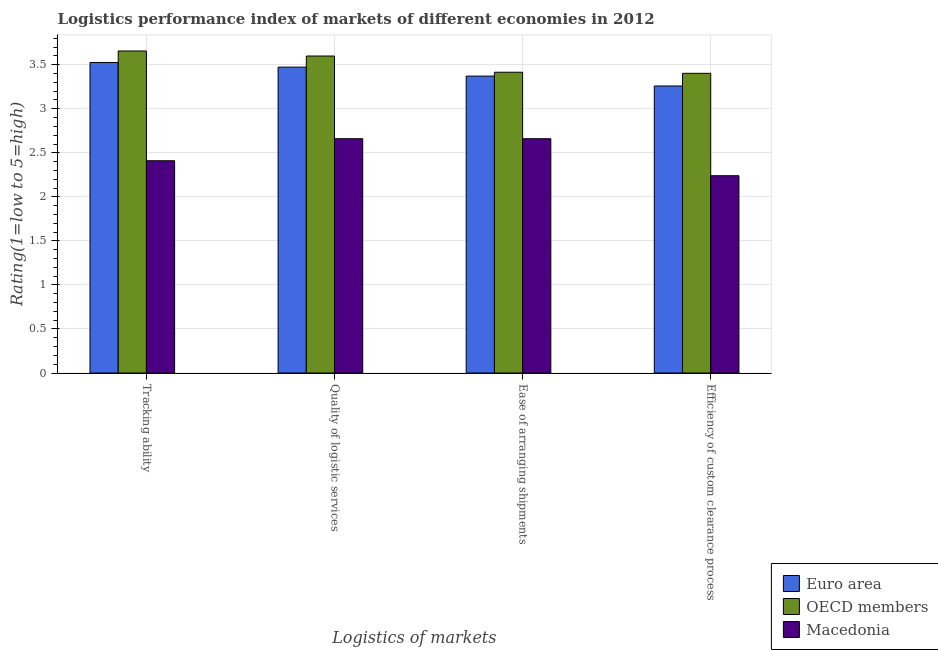How many groups of bars are there?
Your answer should be compact. 4. Are the number of bars per tick equal to the number of legend labels?
Provide a short and direct response. Yes. How many bars are there on the 4th tick from the right?
Give a very brief answer. 3. What is the label of the 3rd group of bars from the left?
Offer a terse response. Ease of arranging shipments. What is the lpi rating of tracking ability in Macedonia?
Your answer should be compact. 2.41. Across all countries, what is the maximum lpi rating of ease of arranging shipments?
Ensure brevity in your answer.  3.42. Across all countries, what is the minimum lpi rating of efficiency of custom clearance process?
Ensure brevity in your answer.  2.24. In which country was the lpi rating of quality of logistic services minimum?
Your answer should be compact. Macedonia. What is the total lpi rating of ease of arranging shipments in the graph?
Offer a terse response. 9.45. What is the difference between the lpi rating of ease of arranging shipments in Macedonia and that in Euro area?
Give a very brief answer. -0.71. What is the difference between the lpi rating of ease of arranging shipments in Macedonia and the lpi rating of tracking ability in OECD members?
Give a very brief answer. -1. What is the average lpi rating of quality of logistic services per country?
Ensure brevity in your answer.  3.24. What is the difference between the lpi rating of tracking ability and lpi rating of ease of arranging shipments in Euro area?
Offer a terse response. 0.15. In how many countries, is the lpi rating of quality of logistic services greater than 2 ?
Provide a succinct answer. 3. What is the ratio of the lpi rating of ease of arranging shipments in OECD members to that in Euro area?
Give a very brief answer. 1.01. Is the difference between the lpi rating of ease of arranging shipments in OECD members and Euro area greater than the difference between the lpi rating of tracking ability in OECD members and Euro area?
Make the answer very short. No. What is the difference between the highest and the second highest lpi rating of ease of arranging shipments?
Your answer should be compact. 0.04. What is the difference between the highest and the lowest lpi rating of tracking ability?
Your response must be concise. 1.25. Is the sum of the lpi rating of efficiency of custom clearance process in Macedonia and Euro area greater than the maximum lpi rating of tracking ability across all countries?
Provide a short and direct response. Yes. What does the 2nd bar from the left in Tracking ability represents?
Your answer should be compact. OECD members. What does the 1st bar from the right in Tracking ability represents?
Your answer should be compact. Macedonia. Is it the case that in every country, the sum of the lpi rating of tracking ability and lpi rating of quality of logistic services is greater than the lpi rating of ease of arranging shipments?
Make the answer very short. Yes. How many bars are there?
Provide a succinct answer. 12. How many countries are there in the graph?
Provide a succinct answer. 3. What is the difference between two consecutive major ticks on the Y-axis?
Keep it short and to the point. 0.5. Are the values on the major ticks of Y-axis written in scientific E-notation?
Your answer should be very brief. No. Does the graph contain grids?
Ensure brevity in your answer.  Yes. Where does the legend appear in the graph?
Keep it short and to the point. Bottom right. How many legend labels are there?
Ensure brevity in your answer.  3. How are the legend labels stacked?
Your response must be concise. Vertical. What is the title of the graph?
Provide a succinct answer. Logistics performance index of markets of different economies in 2012. What is the label or title of the X-axis?
Your answer should be compact. Logistics of markets. What is the label or title of the Y-axis?
Offer a very short reply. Rating(1=low to 5=high). What is the Rating(1=low to 5=high) in Euro area in Tracking ability?
Keep it short and to the point. 3.53. What is the Rating(1=low to 5=high) in OECD members in Tracking ability?
Offer a terse response. 3.66. What is the Rating(1=low to 5=high) of Macedonia in Tracking ability?
Provide a short and direct response. 2.41. What is the Rating(1=low to 5=high) of Euro area in Quality of logistic services?
Your response must be concise. 3.47. What is the Rating(1=low to 5=high) in OECD members in Quality of logistic services?
Give a very brief answer. 3.6. What is the Rating(1=low to 5=high) of Macedonia in Quality of logistic services?
Give a very brief answer. 2.66. What is the Rating(1=low to 5=high) in Euro area in Ease of arranging shipments?
Keep it short and to the point. 3.37. What is the Rating(1=low to 5=high) in OECD members in Ease of arranging shipments?
Provide a short and direct response. 3.42. What is the Rating(1=low to 5=high) in Macedonia in Ease of arranging shipments?
Provide a succinct answer. 2.66. What is the Rating(1=low to 5=high) in Euro area in Efficiency of custom clearance process?
Ensure brevity in your answer.  3.26. What is the Rating(1=low to 5=high) in OECD members in Efficiency of custom clearance process?
Provide a succinct answer. 3.4. What is the Rating(1=low to 5=high) in Macedonia in Efficiency of custom clearance process?
Provide a short and direct response. 2.24. Across all Logistics of markets, what is the maximum Rating(1=low to 5=high) of Euro area?
Ensure brevity in your answer.  3.53. Across all Logistics of markets, what is the maximum Rating(1=low to 5=high) of OECD members?
Offer a terse response. 3.66. Across all Logistics of markets, what is the maximum Rating(1=low to 5=high) of Macedonia?
Your response must be concise. 2.66. Across all Logistics of markets, what is the minimum Rating(1=low to 5=high) in Euro area?
Your answer should be compact. 3.26. Across all Logistics of markets, what is the minimum Rating(1=low to 5=high) of OECD members?
Give a very brief answer. 3.4. Across all Logistics of markets, what is the minimum Rating(1=low to 5=high) in Macedonia?
Keep it short and to the point. 2.24. What is the total Rating(1=low to 5=high) in Euro area in the graph?
Ensure brevity in your answer.  13.63. What is the total Rating(1=low to 5=high) of OECD members in the graph?
Give a very brief answer. 14.07. What is the total Rating(1=low to 5=high) of Macedonia in the graph?
Make the answer very short. 9.97. What is the difference between the Rating(1=low to 5=high) of Euro area in Tracking ability and that in Quality of logistic services?
Your response must be concise. 0.05. What is the difference between the Rating(1=low to 5=high) in OECD members in Tracking ability and that in Quality of logistic services?
Give a very brief answer. 0.06. What is the difference between the Rating(1=low to 5=high) of Macedonia in Tracking ability and that in Quality of logistic services?
Ensure brevity in your answer.  -0.25. What is the difference between the Rating(1=low to 5=high) in Euro area in Tracking ability and that in Ease of arranging shipments?
Give a very brief answer. 0.15. What is the difference between the Rating(1=low to 5=high) in OECD members in Tracking ability and that in Ease of arranging shipments?
Your response must be concise. 0.24. What is the difference between the Rating(1=low to 5=high) in Macedonia in Tracking ability and that in Ease of arranging shipments?
Make the answer very short. -0.25. What is the difference between the Rating(1=low to 5=high) in Euro area in Tracking ability and that in Efficiency of custom clearance process?
Provide a short and direct response. 0.27. What is the difference between the Rating(1=low to 5=high) of OECD members in Tracking ability and that in Efficiency of custom clearance process?
Ensure brevity in your answer.  0.25. What is the difference between the Rating(1=low to 5=high) in Macedonia in Tracking ability and that in Efficiency of custom clearance process?
Your response must be concise. 0.17. What is the difference between the Rating(1=low to 5=high) in Euro area in Quality of logistic services and that in Ease of arranging shipments?
Give a very brief answer. 0.1. What is the difference between the Rating(1=low to 5=high) in OECD members in Quality of logistic services and that in Ease of arranging shipments?
Ensure brevity in your answer.  0.18. What is the difference between the Rating(1=low to 5=high) in Euro area in Quality of logistic services and that in Efficiency of custom clearance process?
Make the answer very short. 0.21. What is the difference between the Rating(1=low to 5=high) in OECD members in Quality of logistic services and that in Efficiency of custom clearance process?
Offer a terse response. 0.2. What is the difference between the Rating(1=low to 5=high) in Macedonia in Quality of logistic services and that in Efficiency of custom clearance process?
Provide a short and direct response. 0.42. What is the difference between the Rating(1=low to 5=high) of Euro area in Ease of arranging shipments and that in Efficiency of custom clearance process?
Keep it short and to the point. 0.11. What is the difference between the Rating(1=low to 5=high) of OECD members in Ease of arranging shipments and that in Efficiency of custom clearance process?
Your response must be concise. 0.01. What is the difference between the Rating(1=low to 5=high) in Macedonia in Ease of arranging shipments and that in Efficiency of custom clearance process?
Keep it short and to the point. 0.42. What is the difference between the Rating(1=low to 5=high) in Euro area in Tracking ability and the Rating(1=low to 5=high) in OECD members in Quality of logistic services?
Your response must be concise. -0.07. What is the difference between the Rating(1=low to 5=high) in Euro area in Tracking ability and the Rating(1=low to 5=high) in Macedonia in Quality of logistic services?
Your answer should be compact. 0.87. What is the difference between the Rating(1=low to 5=high) in Euro area in Tracking ability and the Rating(1=low to 5=high) in OECD members in Ease of arranging shipments?
Keep it short and to the point. 0.11. What is the difference between the Rating(1=low to 5=high) in Euro area in Tracking ability and the Rating(1=low to 5=high) in Macedonia in Ease of arranging shipments?
Your answer should be compact. 0.87. What is the difference between the Rating(1=low to 5=high) in Euro area in Tracking ability and the Rating(1=low to 5=high) in OECD members in Efficiency of custom clearance process?
Keep it short and to the point. 0.12. What is the difference between the Rating(1=low to 5=high) in Euro area in Tracking ability and the Rating(1=low to 5=high) in Macedonia in Efficiency of custom clearance process?
Your answer should be very brief. 1.29. What is the difference between the Rating(1=low to 5=high) of OECD members in Tracking ability and the Rating(1=low to 5=high) of Macedonia in Efficiency of custom clearance process?
Offer a terse response. 1.42. What is the difference between the Rating(1=low to 5=high) in Euro area in Quality of logistic services and the Rating(1=low to 5=high) in OECD members in Ease of arranging shipments?
Offer a terse response. 0.06. What is the difference between the Rating(1=low to 5=high) in Euro area in Quality of logistic services and the Rating(1=low to 5=high) in Macedonia in Ease of arranging shipments?
Give a very brief answer. 0.81. What is the difference between the Rating(1=low to 5=high) in OECD members in Quality of logistic services and the Rating(1=low to 5=high) in Macedonia in Ease of arranging shipments?
Keep it short and to the point. 0.94. What is the difference between the Rating(1=low to 5=high) in Euro area in Quality of logistic services and the Rating(1=low to 5=high) in OECD members in Efficiency of custom clearance process?
Make the answer very short. 0.07. What is the difference between the Rating(1=low to 5=high) of Euro area in Quality of logistic services and the Rating(1=low to 5=high) of Macedonia in Efficiency of custom clearance process?
Your response must be concise. 1.23. What is the difference between the Rating(1=low to 5=high) in OECD members in Quality of logistic services and the Rating(1=low to 5=high) in Macedonia in Efficiency of custom clearance process?
Ensure brevity in your answer.  1.36. What is the difference between the Rating(1=low to 5=high) in Euro area in Ease of arranging shipments and the Rating(1=low to 5=high) in OECD members in Efficiency of custom clearance process?
Keep it short and to the point. -0.03. What is the difference between the Rating(1=low to 5=high) of Euro area in Ease of arranging shipments and the Rating(1=low to 5=high) of Macedonia in Efficiency of custom clearance process?
Offer a terse response. 1.13. What is the difference between the Rating(1=low to 5=high) of OECD members in Ease of arranging shipments and the Rating(1=low to 5=high) of Macedonia in Efficiency of custom clearance process?
Your answer should be compact. 1.18. What is the average Rating(1=low to 5=high) of Euro area per Logistics of markets?
Keep it short and to the point. 3.41. What is the average Rating(1=low to 5=high) in OECD members per Logistics of markets?
Provide a succinct answer. 3.52. What is the average Rating(1=low to 5=high) in Macedonia per Logistics of markets?
Your answer should be very brief. 2.49. What is the difference between the Rating(1=low to 5=high) in Euro area and Rating(1=low to 5=high) in OECD members in Tracking ability?
Your response must be concise. -0.13. What is the difference between the Rating(1=low to 5=high) in Euro area and Rating(1=low to 5=high) in Macedonia in Tracking ability?
Provide a short and direct response. 1.12. What is the difference between the Rating(1=low to 5=high) in OECD members and Rating(1=low to 5=high) in Macedonia in Tracking ability?
Make the answer very short. 1.25. What is the difference between the Rating(1=low to 5=high) in Euro area and Rating(1=low to 5=high) in OECD members in Quality of logistic services?
Give a very brief answer. -0.13. What is the difference between the Rating(1=low to 5=high) in Euro area and Rating(1=low to 5=high) in Macedonia in Quality of logistic services?
Provide a succinct answer. 0.81. What is the difference between the Rating(1=low to 5=high) in OECD members and Rating(1=low to 5=high) in Macedonia in Quality of logistic services?
Offer a very short reply. 0.94. What is the difference between the Rating(1=low to 5=high) in Euro area and Rating(1=low to 5=high) in OECD members in Ease of arranging shipments?
Your answer should be compact. -0.04. What is the difference between the Rating(1=low to 5=high) of Euro area and Rating(1=low to 5=high) of Macedonia in Ease of arranging shipments?
Your response must be concise. 0.71. What is the difference between the Rating(1=low to 5=high) in OECD members and Rating(1=low to 5=high) in Macedonia in Ease of arranging shipments?
Offer a terse response. 0.76. What is the difference between the Rating(1=low to 5=high) in Euro area and Rating(1=low to 5=high) in OECD members in Efficiency of custom clearance process?
Keep it short and to the point. -0.14. What is the difference between the Rating(1=low to 5=high) in Euro area and Rating(1=low to 5=high) in Macedonia in Efficiency of custom clearance process?
Your answer should be compact. 1.02. What is the difference between the Rating(1=low to 5=high) in OECD members and Rating(1=low to 5=high) in Macedonia in Efficiency of custom clearance process?
Keep it short and to the point. 1.16. What is the ratio of the Rating(1=low to 5=high) in Euro area in Tracking ability to that in Quality of logistic services?
Your answer should be compact. 1.02. What is the ratio of the Rating(1=low to 5=high) in OECD members in Tracking ability to that in Quality of logistic services?
Your answer should be compact. 1.02. What is the ratio of the Rating(1=low to 5=high) of Macedonia in Tracking ability to that in Quality of logistic services?
Provide a short and direct response. 0.91. What is the ratio of the Rating(1=low to 5=high) of Euro area in Tracking ability to that in Ease of arranging shipments?
Your answer should be compact. 1.05. What is the ratio of the Rating(1=low to 5=high) in OECD members in Tracking ability to that in Ease of arranging shipments?
Give a very brief answer. 1.07. What is the ratio of the Rating(1=low to 5=high) of Macedonia in Tracking ability to that in Ease of arranging shipments?
Make the answer very short. 0.91. What is the ratio of the Rating(1=low to 5=high) of Euro area in Tracking ability to that in Efficiency of custom clearance process?
Give a very brief answer. 1.08. What is the ratio of the Rating(1=low to 5=high) of OECD members in Tracking ability to that in Efficiency of custom clearance process?
Your response must be concise. 1.07. What is the ratio of the Rating(1=low to 5=high) in Macedonia in Tracking ability to that in Efficiency of custom clearance process?
Make the answer very short. 1.08. What is the ratio of the Rating(1=low to 5=high) in Euro area in Quality of logistic services to that in Ease of arranging shipments?
Give a very brief answer. 1.03. What is the ratio of the Rating(1=low to 5=high) of OECD members in Quality of logistic services to that in Ease of arranging shipments?
Keep it short and to the point. 1.05. What is the ratio of the Rating(1=low to 5=high) of Euro area in Quality of logistic services to that in Efficiency of custom clearance process?
Your answer should be very brief. 1.07. What is the ratio of the Rating(1=low to 5=high) in OECD members in Quality of logistic services to that in Efficiency of custom clearance process?
Give a very brief answer. 1.06. What is the ratio of the Rating(1=low to 5=high) of Macedonia in Quality of logistic services to that in Efficiency of custom clearance process?
Keep it short and to the point. 1.19. What is the ratio of the Rating(1=low to 5=high) of Euro area in Ease of arranging shipments to that in Efficiency of custom clearance process?
Give a very brief answer. 1.03. What is the ratio of the Rating(1=low to 5=high) in Macedonia in Ease of arranging shipments to that in Efficiency of custom clearance process?
Make the answer very short. 1.19. What is the difference between the highest and the second highest Rating(1=low to 5=high) in Euro area?
Make the answer very short. 0.05. What is the difference between the highest and the second highest Rating(1=low to 5=high) in OECD members?
Your response must be concise. 0.06. What is the difference between the highest and the lowest Rating(1=low to 5=high) of Euro area?
Your answer should be very brief. 0.27. What is the difference between the highest and the lowest Rating(1=low to 5=high) of OECD members?
Offer a terse response. 0.25. What is the difference between the highest and the lowest Rating(1=low to 5=high) of Macedonia?
Your answer should be compact. 0.42. 